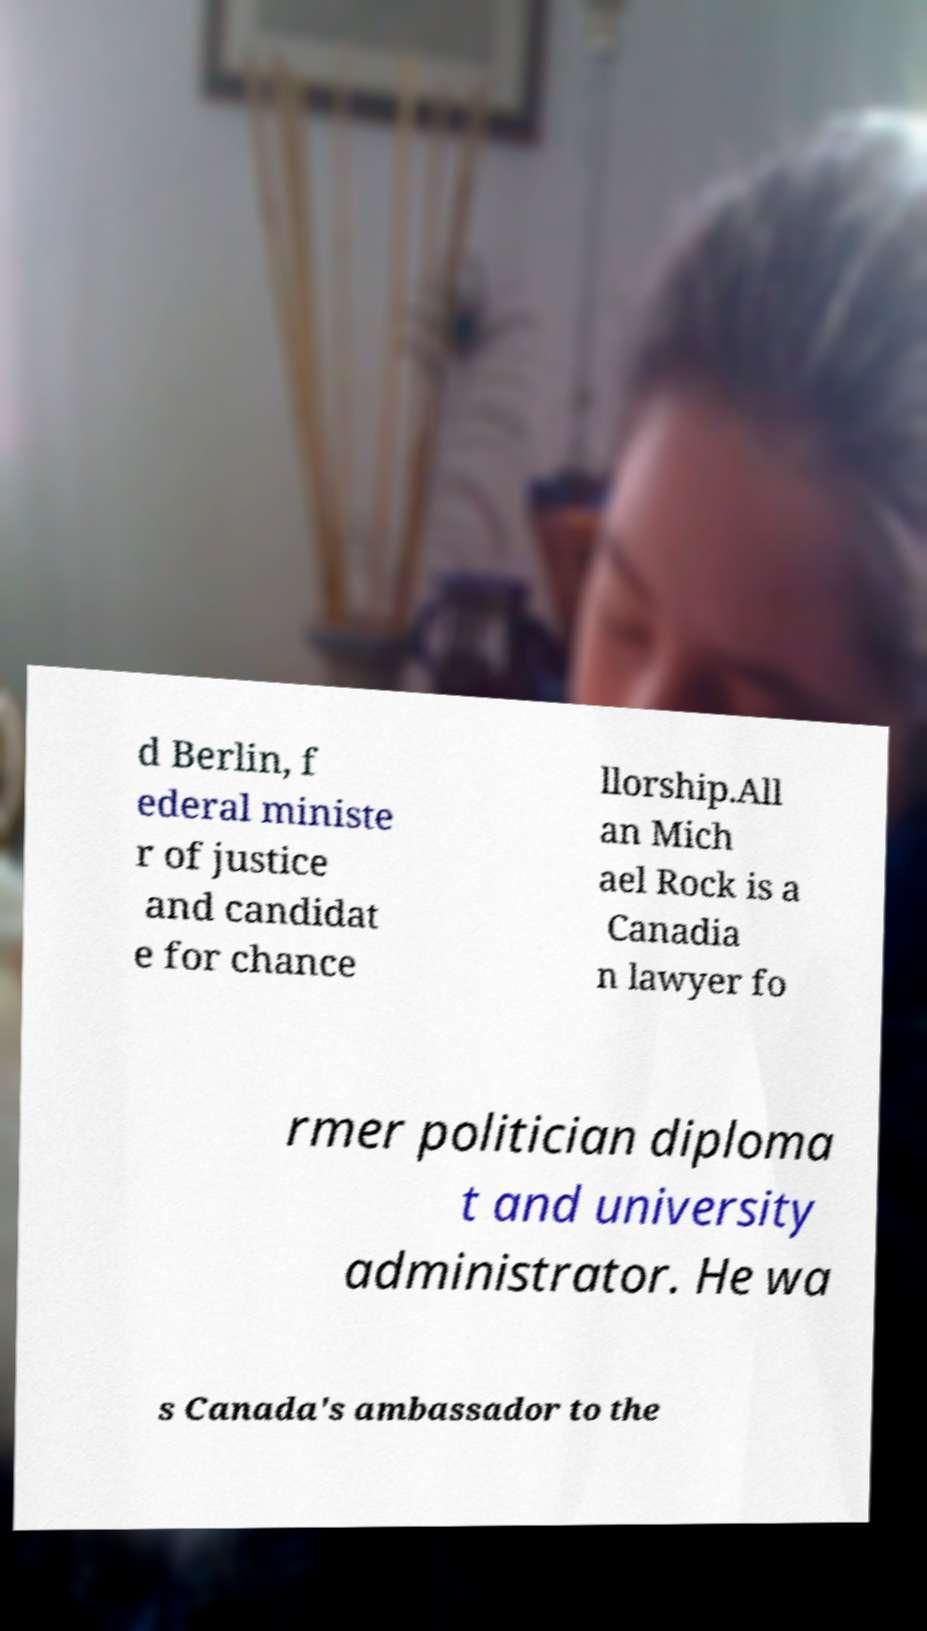Please read and relay the text visible in this image. What does it say? d Berlin, f ederal ministe r of justice and candidat e for chance llorship.All an Mich ael Rock is a Canadia n lawyer fo rmer politician diploma t and university administrator. He wa s Canada's ambassador to the 